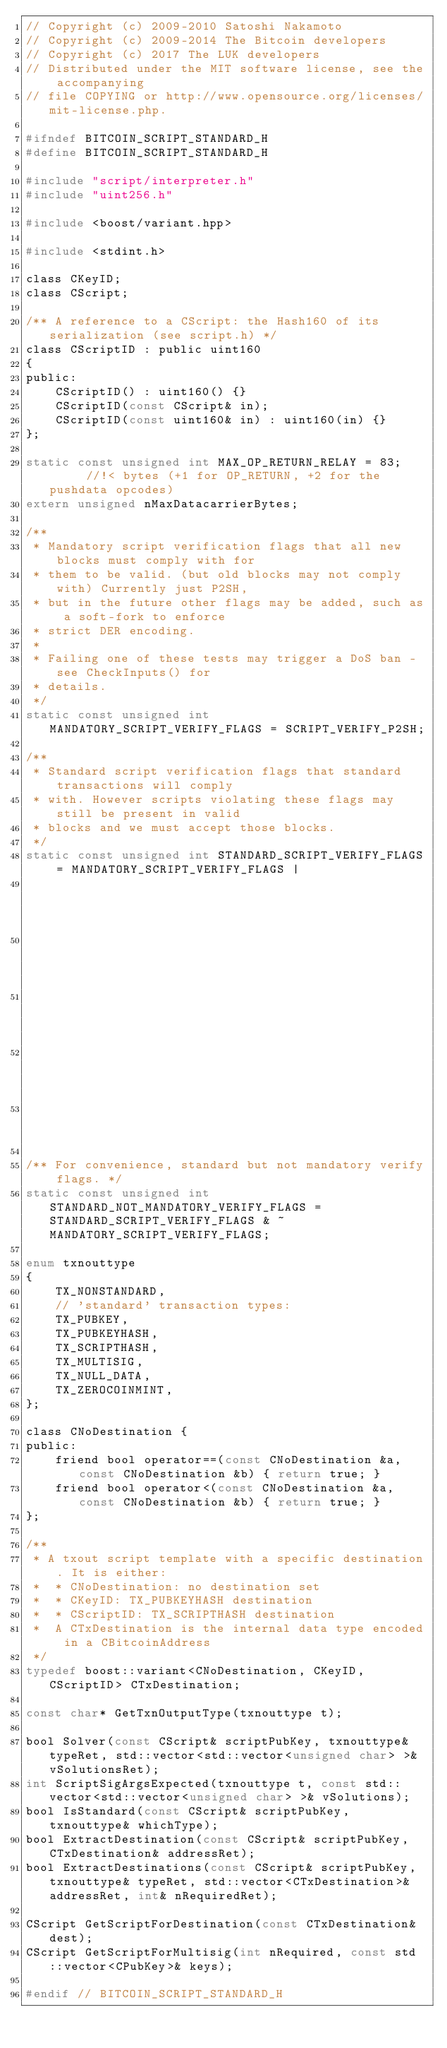<code> <loc_0><loc_0><loc_500><loc_500><_C_>// Copyright (c) 2009-2010 Satoshi Nakamoto
// Copyright (c) 2009-2014 The Bitcoin developers
// Copyright (c) 2017 The LUK developers
// Distributed under the MIT software license, see the accompanying
// file COPYING or http://www.opensource.org/licenses/mit-license.php.

#ifndef BITCOIN_SCRIPT_STANDARD_H
#define BITCOIN_SCRIPT_STANDARD_H

#include "script/interpreter.h"
#include "uint256.h"

#include <boost/variant.hpp>

#include <stdint.h>

class CKeyID;
class CScript;

/** A reference to a CScript: the Hash160 of its serialization (see script.h) */
class CScriptID : public uint160
{
public:
    CScriptID() : uint160() {}
    CScriptID(const CScript& in);
    CScriptID(const uint160& in) : uint160(in) {}
};

static const unsigned int MAX_OP_RETURN_RELAY = 83;      //!< bytes (+1 for OP_RETURN, +2 for the pushdata opcodes)
extern unsigned nMaxDatacarrierBytes;

/**
 * Mandatory script verification flags that all new blocks must comply with for
 * them to be valid. (but old blocks may not comply with) Currently just P2SH,
 * but in the future other flags may be added, such as a soft-fork to enforce
 * strict DER encoding.
 * 
 * Failing one of these tests may trigger a DoS ban - see CheckInputs() for
 * details.
 */
static const unsigned int MANDATORY_SCRIPT_VERIFY_FLAGS = SCRIPT_VERIFY_P2SH;

/**
 * Standard script verification flags that standard transactions will comply
 * with. However scripts violating these flags may still be present in valid
 * blocks and we must accept those blocks.
 */
static const unsigned int STANDARD_SCRIPT_VERIFY_FLAGS = MANDATORY_SCRIPT_VERIFY_FLAGS |
                                                         SCRIPT_VERIFY_DERSIG |
                                                         SCRIPT_VERIFY_STRICTENC |
                                                         SCRIPT_VERIFY_MINIMALDATA |
                                                         SCRIPT_VERIFY_NULLDUMMY |
                                                         SCRIPT_VERIFY_DISCOURAGE_UPGRADABLE_NOPS;

/** For convenience, standard but not mandatory verify flags. */
static const unsigned int STANDARD_NOT_MANDATORY_VERIFY_FLAGS = STANDARD_SCRIPT_VERIFY_FLAGS & ~MANDATORY_SCRIPT_VERIFY_FLAGS;

enum txnouttype
{
    TX_NONSTANDARD,
    // 'standard' transaction types:
    TX_PUBKEY,
    TX_PUBKEYHASH,
    TX_SCRIPTHASH,
    TX_MULTISIG,
    TX_NULL_DATA,
    TX_ZEROCOINMINT,
};

class CNoDestination {
public:
    friend bool operator==(const CNoDestination &a, const CNoDestination &b) { return true; }
    friend bool operator<(const CNoDestination &a, const CNoDestination &b) { return true; }
};

/** 
 * A txout script template with a specific destination. It is either:
 *  * CNoDestination: no destination set
 *  * CKeyID: TX_PUBKEYHASH destination
 *  * CScriptID: TX_SCRIPTHASH destination
 *  A CTxDestination is the internal data type encoded in a CBitcoinAddress
 */
typedef boost::variant<CNoDestination, CKeyID, CScriptID> CTxDestination;

const char* GetTxnOutputType(txnouttype t);

bool Solver(const CScript& scriptPubKey, txnouttype& typeRet, std::vector<std::vector<unsigned char> >& vSolutionsRet);
int ScriptSigArgsExpected(txnouttype t, const std::vector<std::vector<unsigned char> >& vSolutions);
bool IsStandard(const CScript& scriptPubKey, txnouttype& whichType);
bool ExtractDestination(const CScript& scriptPubKey, CTxDestination& addressRet);
bool ExtractDestinations(const CScript& scriptPubKey, txnouttype& typeRet, std::vector<CTxDestination>& addressRet, int& nRequiredRet);

CScript GetScriptForDestination(const CTxDestination& dest);
CScript GetScriptForMultisig(int nRequired, const std::vector<CPubKey>& keys);

#endif // BITCOIN_SCRIPT_STANDARD_H
</code> 